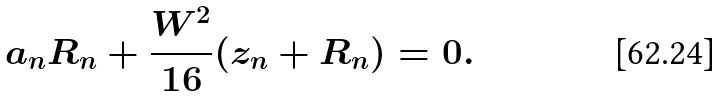<formula> <loc_0><loc_0><loc_500><loc_500>a _ { n } R _ { n } + \frac { W ^ { 2 } } { 1 6 } ( z _ { n } + R _ { n } ) = 0 .</formula> 